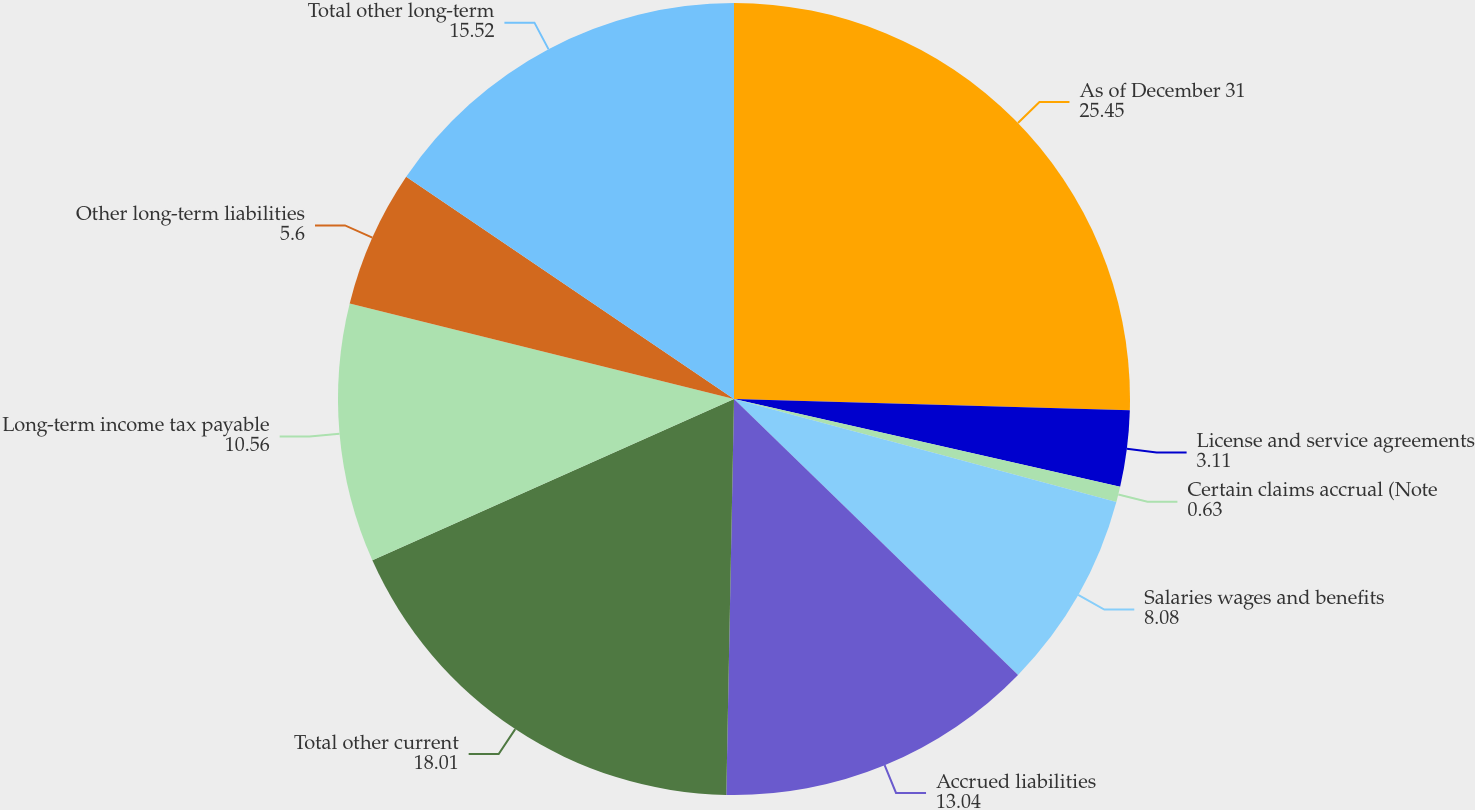Convert chart to OTSL. <chart><loc_0><loc_0><loc_500><loc_500><pie_chart><fcel>As of December 31<fcel>License and service agreements<fcel>Certain claims accrual (Note<fcel>Salaries wages and benefits<fcel>Accrued liabilities<fcel>Total other current<fcel>Long-term income tax payable<fcel>Other long-term liabilities<fcel>Total other long-term<nl><fcel>25.45%<fcel>3.11%<fcel>0.63%<fcel>8.08%<fcel>13.04%<fcel>18.01%<fcel>10.56%<fcel>5.6%<fcel>15.52%<nl></chart> 